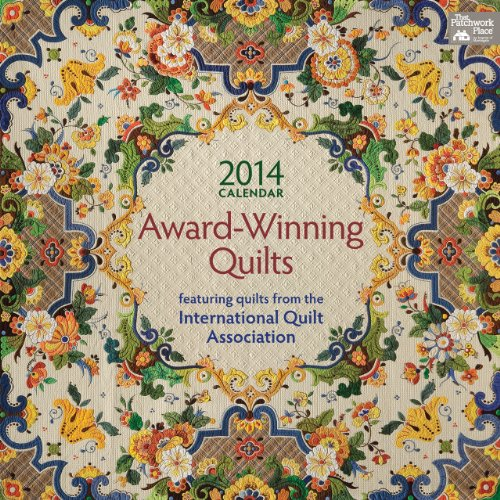What is the title of this book? The title is 'Award Winning Quilts 2014 Calendar: Featuring Quilts from the International Quilt Association', showcasing a collection of quilts that have stood out in international competition. 